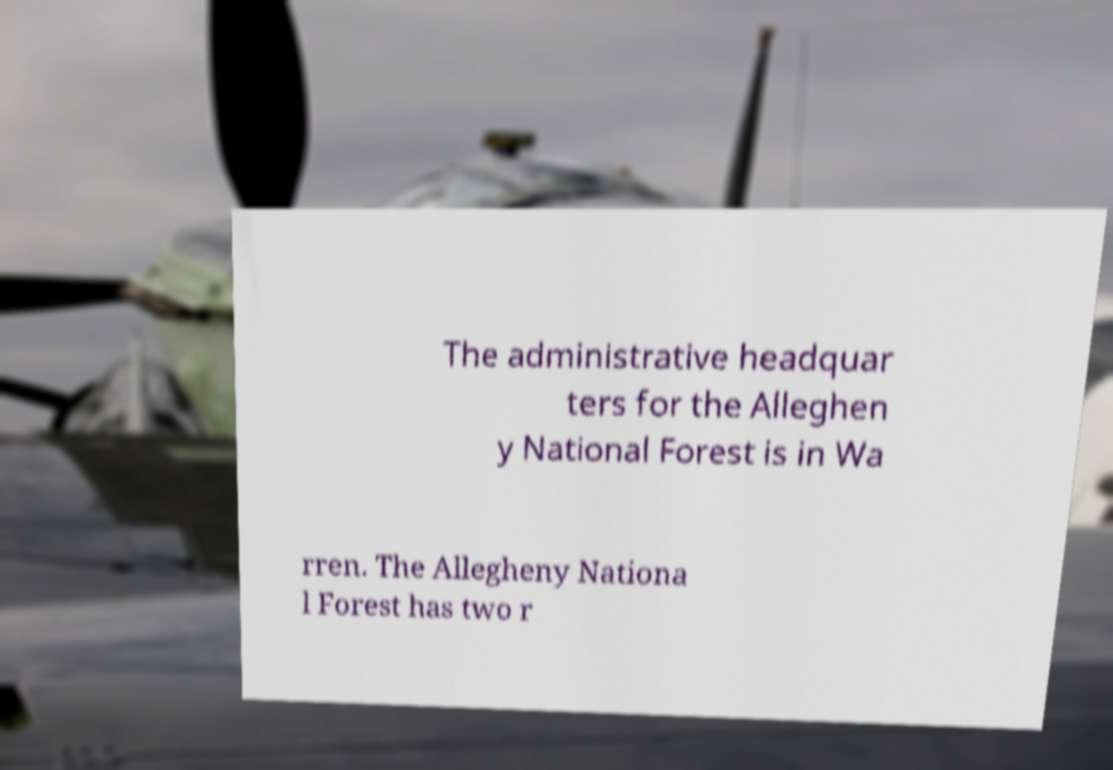Can you read and provide the text displayed in the image?This photo seems to have some interesting text. Can you extract and type it out for me? The administrative headquar ters for the Alleghen y National Forest is in Wa rren. The Allegheny Nationa l Forest has two r 